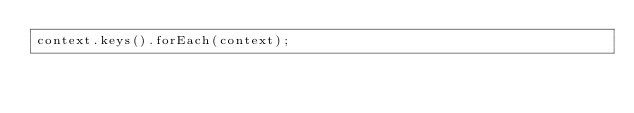<code> <loc_0><loc_0><loc_500><loc_500><_JavaScript_>context.keys().forEach(context);
</code> 